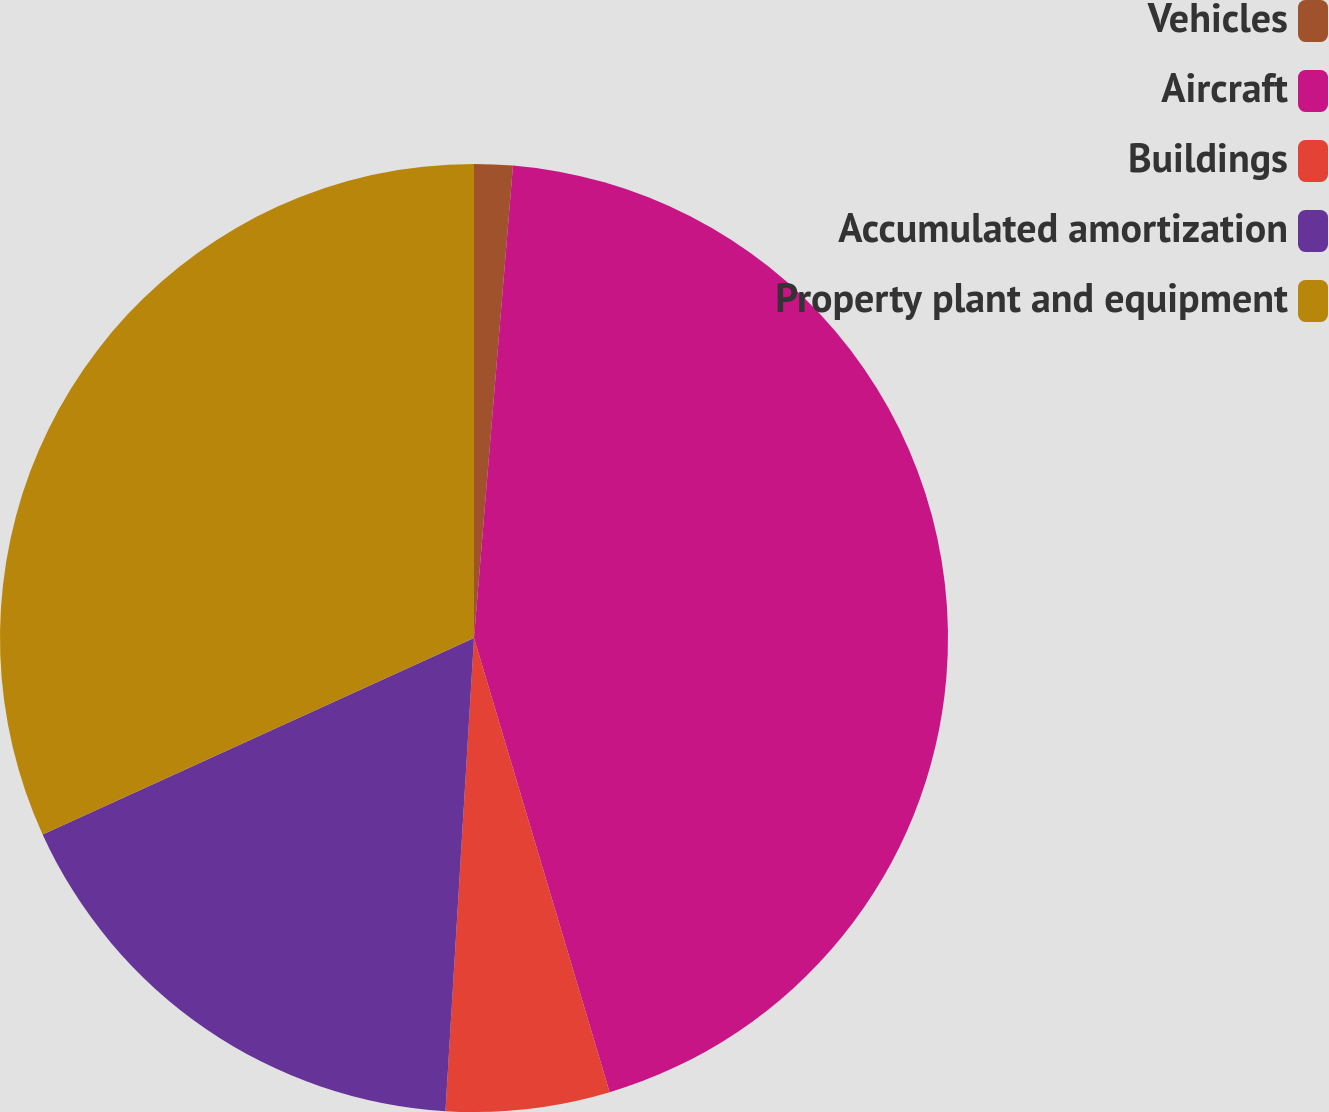<chart> <loc_0><loc_0><loc_500><loc_500><pie_chart><fcel>Vehicles<fcel>Aircraft<fcel>Buildings<fcel>Accumulated amortization<fcel>Property plant and equipment<nl><fcel>1.31%<fcel>44.07%<fcel>5.58%<fcel>17.24%<fcel>31.8%<nl></chart> 